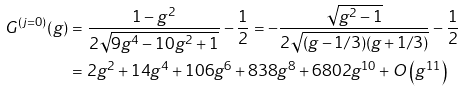Convert formula to latex. <formula><loc_0><loc_0><loc_500><loc_500>G ^ { ( j = 0 ) } ( g ) & = \frac { 1 - g ^ { 2 } } { 2 \sqrt { 9 g ^ { 4 } - 1 0 g ^ { 2 } + 1 } } - \frac { 1 } { 2 } = - \frac { \sqrt { g ^ { 2 } - 1 } } { 2 \sqrt { ( g - 1 / 3 ) ( g + 1 / 3 ) } } - \frac { 1 } { 2 } \\ & = 2 g ^ { 2 } + 1 4 g ^ { 4 } + 1 0 6 g ^ { 6 } + 8 3 8 g ^ { 8 } + 6 8 0 2 g ^ { 1 0 } + O \left ( g ^ { 1 1 } \right )</formula> 